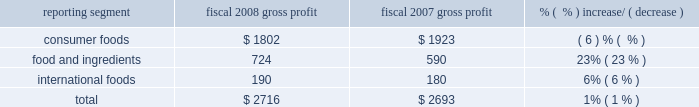Consumer foods net sales increased $ 303 million , or 5% ( 5 % ) , for the year to $ 6.8 billion .
Results reflect an increase of three percentage points from improved net pricing and product mix and two percentage points of improvement from higher volumes .
Net pricing and volume improvements were achieved in many of the company 2019s priority investment and enabler brands .
The impact of product recalls partially offset these improvements .
The company implemented significant price increases for many consumer foods products during the fourth quarter of fiscal 2008 .
Continued net sales improvements are expected into fiscal 2009 when the company expects to receive the benefit of these pricing actions for full fiscal periods .
Sales of some of the company 2019s most significant brands , including chef boyardee ae , david ae , egg beaters ae , healthy choice ae , hebrew national ae , hunt 2019s ae , marie callender 2019s ae , manwich ae , orville redenbacher 2019s ae , pam ae , ro*tel ae , rosarita ae , snack pack ae , swiss miss ae , wesson ae , and wolf ae grew in fiscal 2008 .
Sales of act ii ae , andy capp ae , banquet ae , crunch 2018n munch ae , kid cuisine ae , parkay ae , pemmican ae , reddi-wip ae , and slim jim ae declined in fiscal 2008 .
Net sales in the consumer foods segment are not comparable across periods due to a variety of factors .
The company initiated a peanut butter recall in the third quarter of fiscal 2007 and reintroduced peter pan ae peanut butter products in august 2007 .
Sales of all peanut butter products , including both branded and private label , in fiscal 2008 were $ 14 million lower than comparable amounts in fiscal 2007 .
Consumer foods net sales were also adversely impacted by the recall of banquet ae and private label pot pies in the second quarter of fiscal 2008 .
Net sales of pot pies were lower by approximately $ 22 million in fiscal 2008 , relative to fiscal 2007 , primarily due to product returns and lost sales of banquet ae and private label pot pies .
Sales from alexia foods and lincoln snacks , businesses acquired in fiscal 2008 , totaled $ 66 million in fiscal 2008 .
The company divested a refrigerated pizza business during the first half of fiscal 2007 .
Sales from this business were $ 17 million in fiscal food and ingredients net sales were $ 4.1 billion in fiscal 2008 , an increase of $ 706 million , or 21% ( 21 % ) .
Increased sales are reflective of higher sales prices in the company 2019s milling operations due to higher grain prices , and price and volume increases in the company 2019s potato and dehydrated vegetable operations .
The fiscal 2007 divestiture of an oat milling operation resulted in a reduction of sales of $ 27 million for fiscal 2008 , partially offset by increased sales of $ 18 million from the acquisition of watts brothers in february 2008 .
International foods net sales increased $ 65 million to $ 678 million .
The strengthening of foreign currencies relative to the u.s .
Dollar accounted for approximately $ 36 million of this increase .
The segment achieved a 5% ( 5 % ) increase in sales volume in fiscal 2008 , primarily reflecting increased unit sales in canada and mexico , and modest increases in net pricing .
Gross profit ( net sales less cost of goods sold ) ( $ in millions ) reporting segment fiscal 2008 gross profit fiscal 2007 gross profit % (  % ) increase/ ( decrease ) .
The company 2019s gross profit for fiscal 2008 was $ 2.7 billion , an increase of $ 23 million , or 1% ( 1 % ) , over the prior year .
The increase in gross profit was largely driven by results in the food and ingredients segment , reflecting higher margins in the company 2019s milling and specialty potato operations , largely offset by reduced gross profits in the consumer foods segment .
Costs of implementing the company 2019s restructuring plans reduced gross profit by $ 4 million and $ 46 million in fiscal 2008 and fiscal 2007 , respectively. .
What percent of total gross profit in fiscal 2007 was contributed by consumer foods? 
Computations: (1923 / 2693)
Answer: 0.71407. 